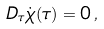Convert formula to latex. <formula><loc_0><loc_0><loc_500><loc_500>D _ { \tau } \dot { \chi } ( \tau ) = 0 \, ,</formula> 